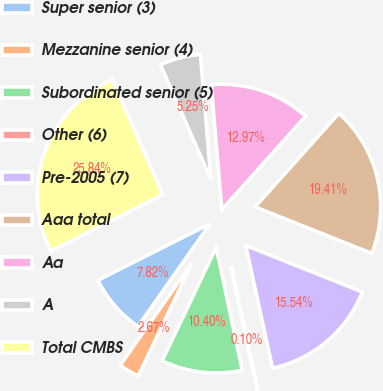Convert chart to OTSL. <chart><loc_0><loc_0><loc_500><loc_500><pie_chart><fcel>Super senior (3)<fcel>Mezzanine senior (4)<fcel>Subordinated senior (5)<fcel>Other (6)<fcel>Pre-2005 (7)<fcel>Aaa total<fcel>Aa<fcel>A<fcel>Total CMBS<nl><fcel>7.82%<fcel>2.67%<fcel>10.4%<fcel>0.1%<fcel>15.54%<fcel>19.41%<fcel>12.97%<fcel>5.25%<fcel>25.84%<nl></chart> 